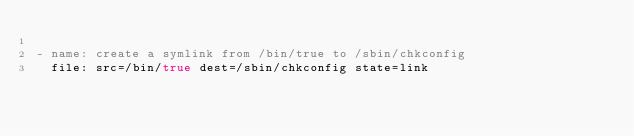Convert code to text. <code><loc_0><loc_0><loc_500><loc_500><_YAML_>
- name: create a symlink from /bin/true to /sbin/chkconfig
  file: src=/bin/true dest=/sbin/chkconfig state=link
</code> 